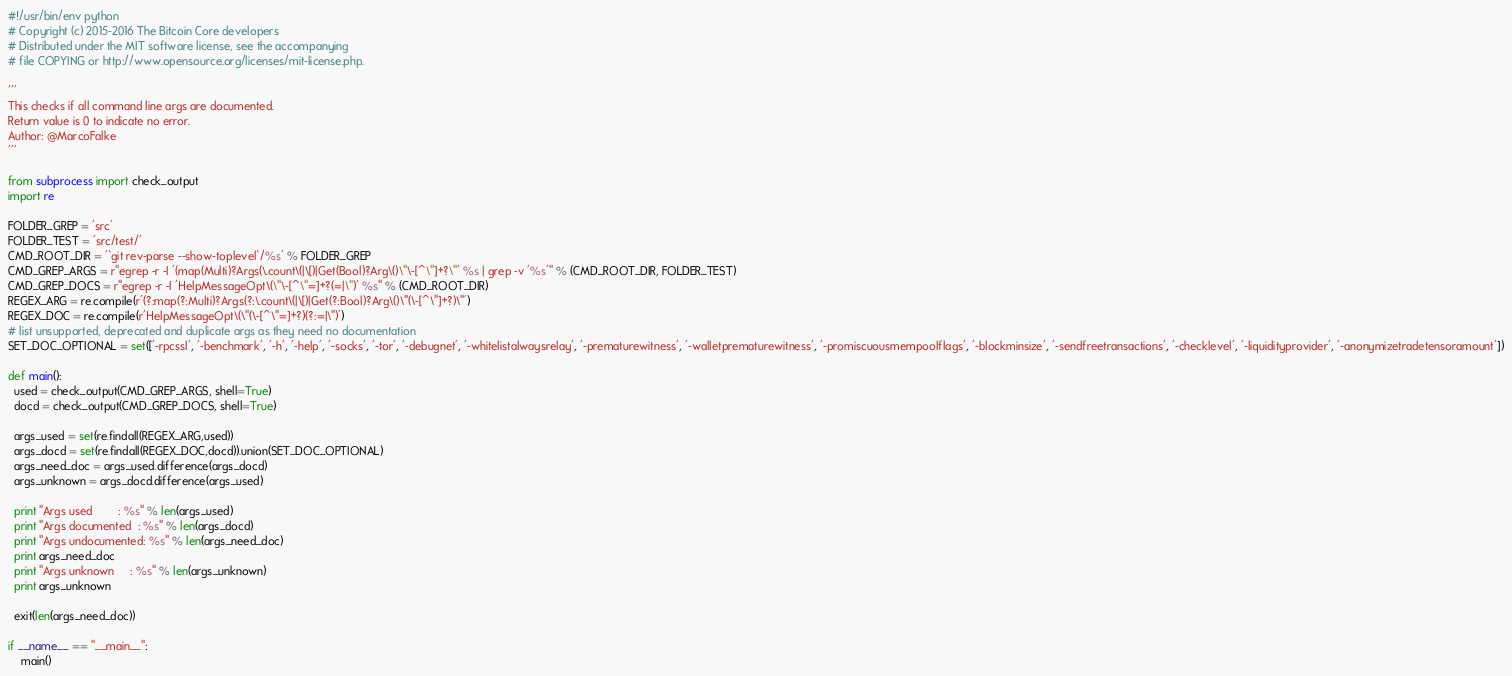<code> <loc_0><loc_0><loc_500><loc_500><_Python_>#!/usr/bin/env python
# Copyright (c) 2015-2016 The Bitcoin Core developers
# Distributed under the MIT software license, see the accompanying
# file COPYING or http://www.opensource.org/licenses/mit-license.php.

'''
This checks if all command line args are documented.
Return value is 0 to indicate no error.
Author: @MarcoFalke
'''

from subprocess import check_output
import re

FOLDER_GREP = 'src'
FOLDER_TEST = 'src/test/'
CMD_ROOT_DIR = '`git rev-parse --show-toplevel`/%s' % FOLDER_GREP
CMD_GREP_ARGS = r"egrep -r -I '(map(Multi)?Args(\.count\(|\[)|Get(Bool)?Arg\()\"\-[^\"]+?\"' %s | grep -v '%s'" % (CMD_ROOT_DIR, FOLDER_TEST)
CMD_GREP_DOCS = r"egrep -r -I 'HelpMessageOpt\(\"\-[^\"=]+?(=|\")' %s" % (CMD_ROOT_DIR)
REGEX_ARG = re.compile(r'(?:map(?:Multi)?Args(?:\.count\(|\[)|Get(?:Bool)?Arg\()\"(\-[^\"]+?)\"')
REGEX_DOC = re.compile(r'HelpMessageOpt\(\"(\-[^\"=]+?)(?:=|\")')
# list unsupported, deprecated and duplicate args as they need no documentation
SET_DOC_OPTIONAL = set(['-rpcssl', '-benchmark', '-h', '-help', '-socks', '-tor', '-debugnet', '-whitelistalwaysrelay', '-prematurewitness', '-walletprematurewitness', '-promiscuousmempoolflags', '-blockminsize', '-sendfreetransactions', '-checklevel', '-liquidityprovider', '-anonymizetradetensoramount'])

def main():
  used = check_output(CMD_GREP_ARGS, shell=True)
  docd = check_output(CMD_GREP_DOCS, shell=True)

  args_used = set(re.findall(REGEX_ARG,used))
  args_docd = set(re.findall(REGEX_DOC,docd)).union(SET_DOC_OPTIONAL)
  args_need_doc = args_used.difference(args_docd)
  args_unknown = args_docd.difference(args_used)

  print "Args used        : %s" % len(args_used)
  print "Args documented  : %s" % len(args_docd)
  print "Args undocumented: %s" % len(args_need_doc)
  print args_need_doc
  print "Args unknown     : %s" % len(args_unknown)
  print args_unknown

  exit(len(args_need_doc))

if __name__ == "__main__":
    main()
</code> 